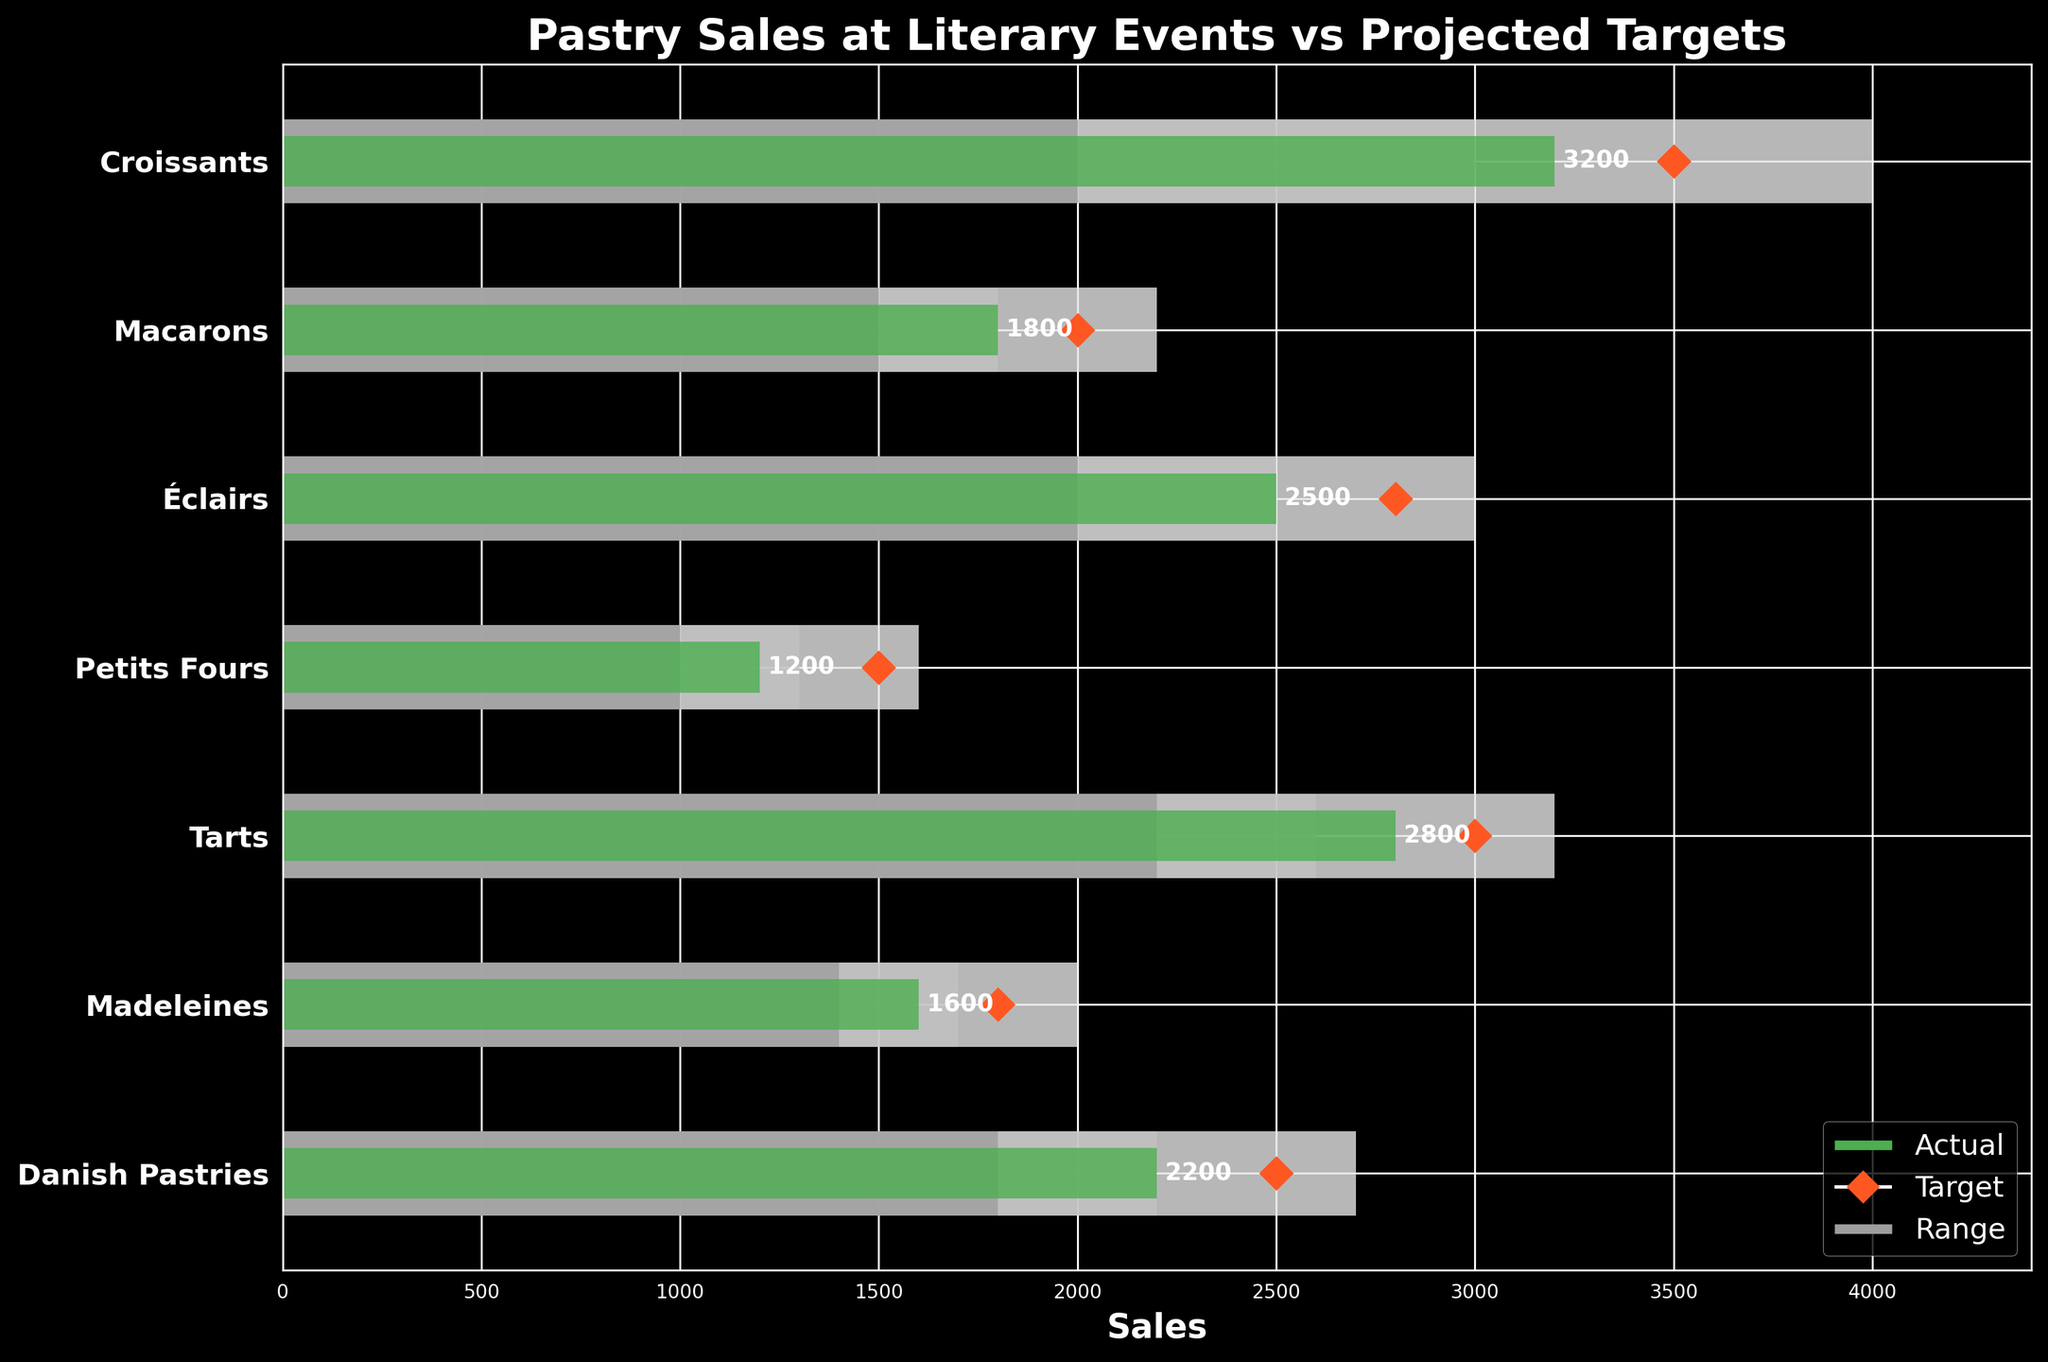Which pastry type has the highest actual sales? Scan the bar chart to identify the highest green bar, which represents the actual sales figure.
Answer: Croissants What is the target sales value for Macarons? Locate the diamond markers on the horizontal line corresponding to Macarons and note the value.
Answer: 2000 How do the actual sales of Éclairs compare to their target? Look at both the green bar representing the actual sales and the diamond marker for the target, then compare the two values.
Answer: Below target by 300 Which pastry types have actual sales that fall within their first range (darkest grey)? Identify the green bars that are within the range of the first darkest grey bar.
Answer: Macarons, Croissants, Éclairs, Tarts, Madeleines, Danish Pastries What are the actual sales values for Petits Fours, and how do they compare to their target values? Look at the length of the green bar for Petits Fours for actual sales and note the position of the diamond marker for target sales. Compare these values.
Answer: Actual: 1200, Below target by 300 Which pastry type has the smallest difference between actual sales and target sales? Subtract the actual sales values from their target values for each pastry type, then find the smallest difference.
Answer: Macarons (difference of 200) Which pastry type has actual sales that exceed their target? Compare the actual sales bars and target markers to see which green bar extends beyond its corresponding diamond marker.
Answer: None How many pastry types have actual sales exceeding their second range (medium grey)? Count the green bars that extend beyond the medium grey range for each pastry type.
Answer: One (Croissants) Arrange the pastry types in descending order of their actual sales values. List all pastry types, ordering by the lengths of their green bars from longest to shortest.
Answer: Croissants, Tarts, Éclairs, Danish Pastries, Macarons, Madeleines, Petits Fours What can be inferred about the overall performance of the pastry sales in comparison to their targets? Observe the general position of actual sales (green bars) relative to their targets (diamond markers) and ranges. Determine if the majority meet, exceed, or fall below their targets.
Answer: Most pastries are below target 